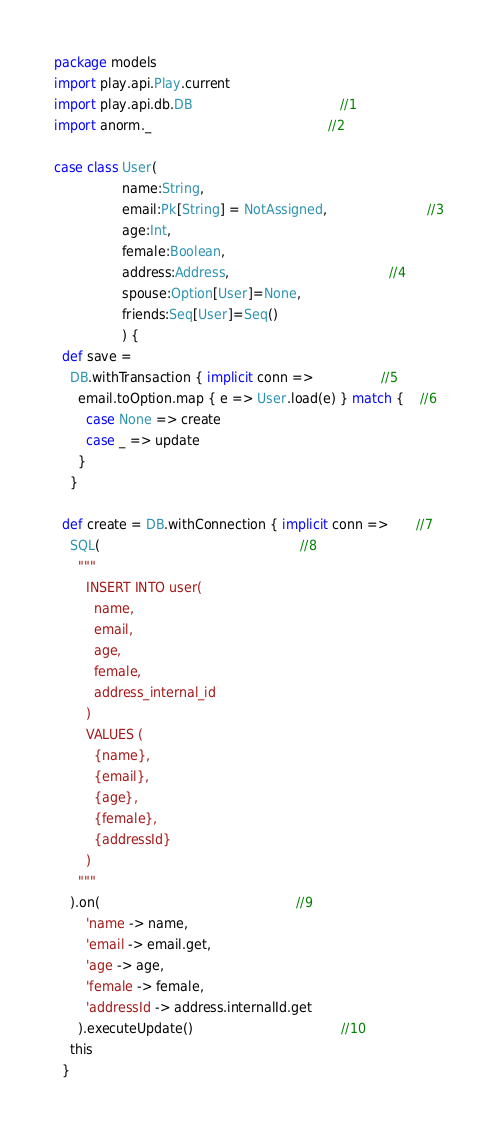Convert code to text. <code><loc_0><loc_0><loc_500><loc_500><_Scala_>package models
import play.api.Play.current
import play.api.db.DB                                     //1
import anorm._                                            //2

case class User(
                 name:String,
                 email:Pk[String] = NotAssigned,                         //3
                 age:Int,
                 female:Boolean,
                 address:Address,                                        //4
                 spouse:Option[User]=None,
                 friends:Seq[User]=Seq()
                 ) {
  def save =
    DB.withTransaction { implicit conn =>                 //5
      email.toOption.map { e => User.load(e) } match {    //6
        case None => create
        case _ => update
      }
    }

  def create = DB.withConnection { implicit conn =>       //7
    SQL(                                                  //8
      """
        INSERT INTO user(
          name,
          email,
          age,
          female,
          address_internal_id
        )
        VALUES (
          {name},
          {email},
          {age},
          {female},
          {addressId}
        )
      """
    ).on(                                                 //9
        'name -> name,
        'email -> email.get,
        'age -> age,
        'female -> female,
        'addressId -> address.internalId.get
      ).executeUpdate()                                     //10
    this
  }
</code> 